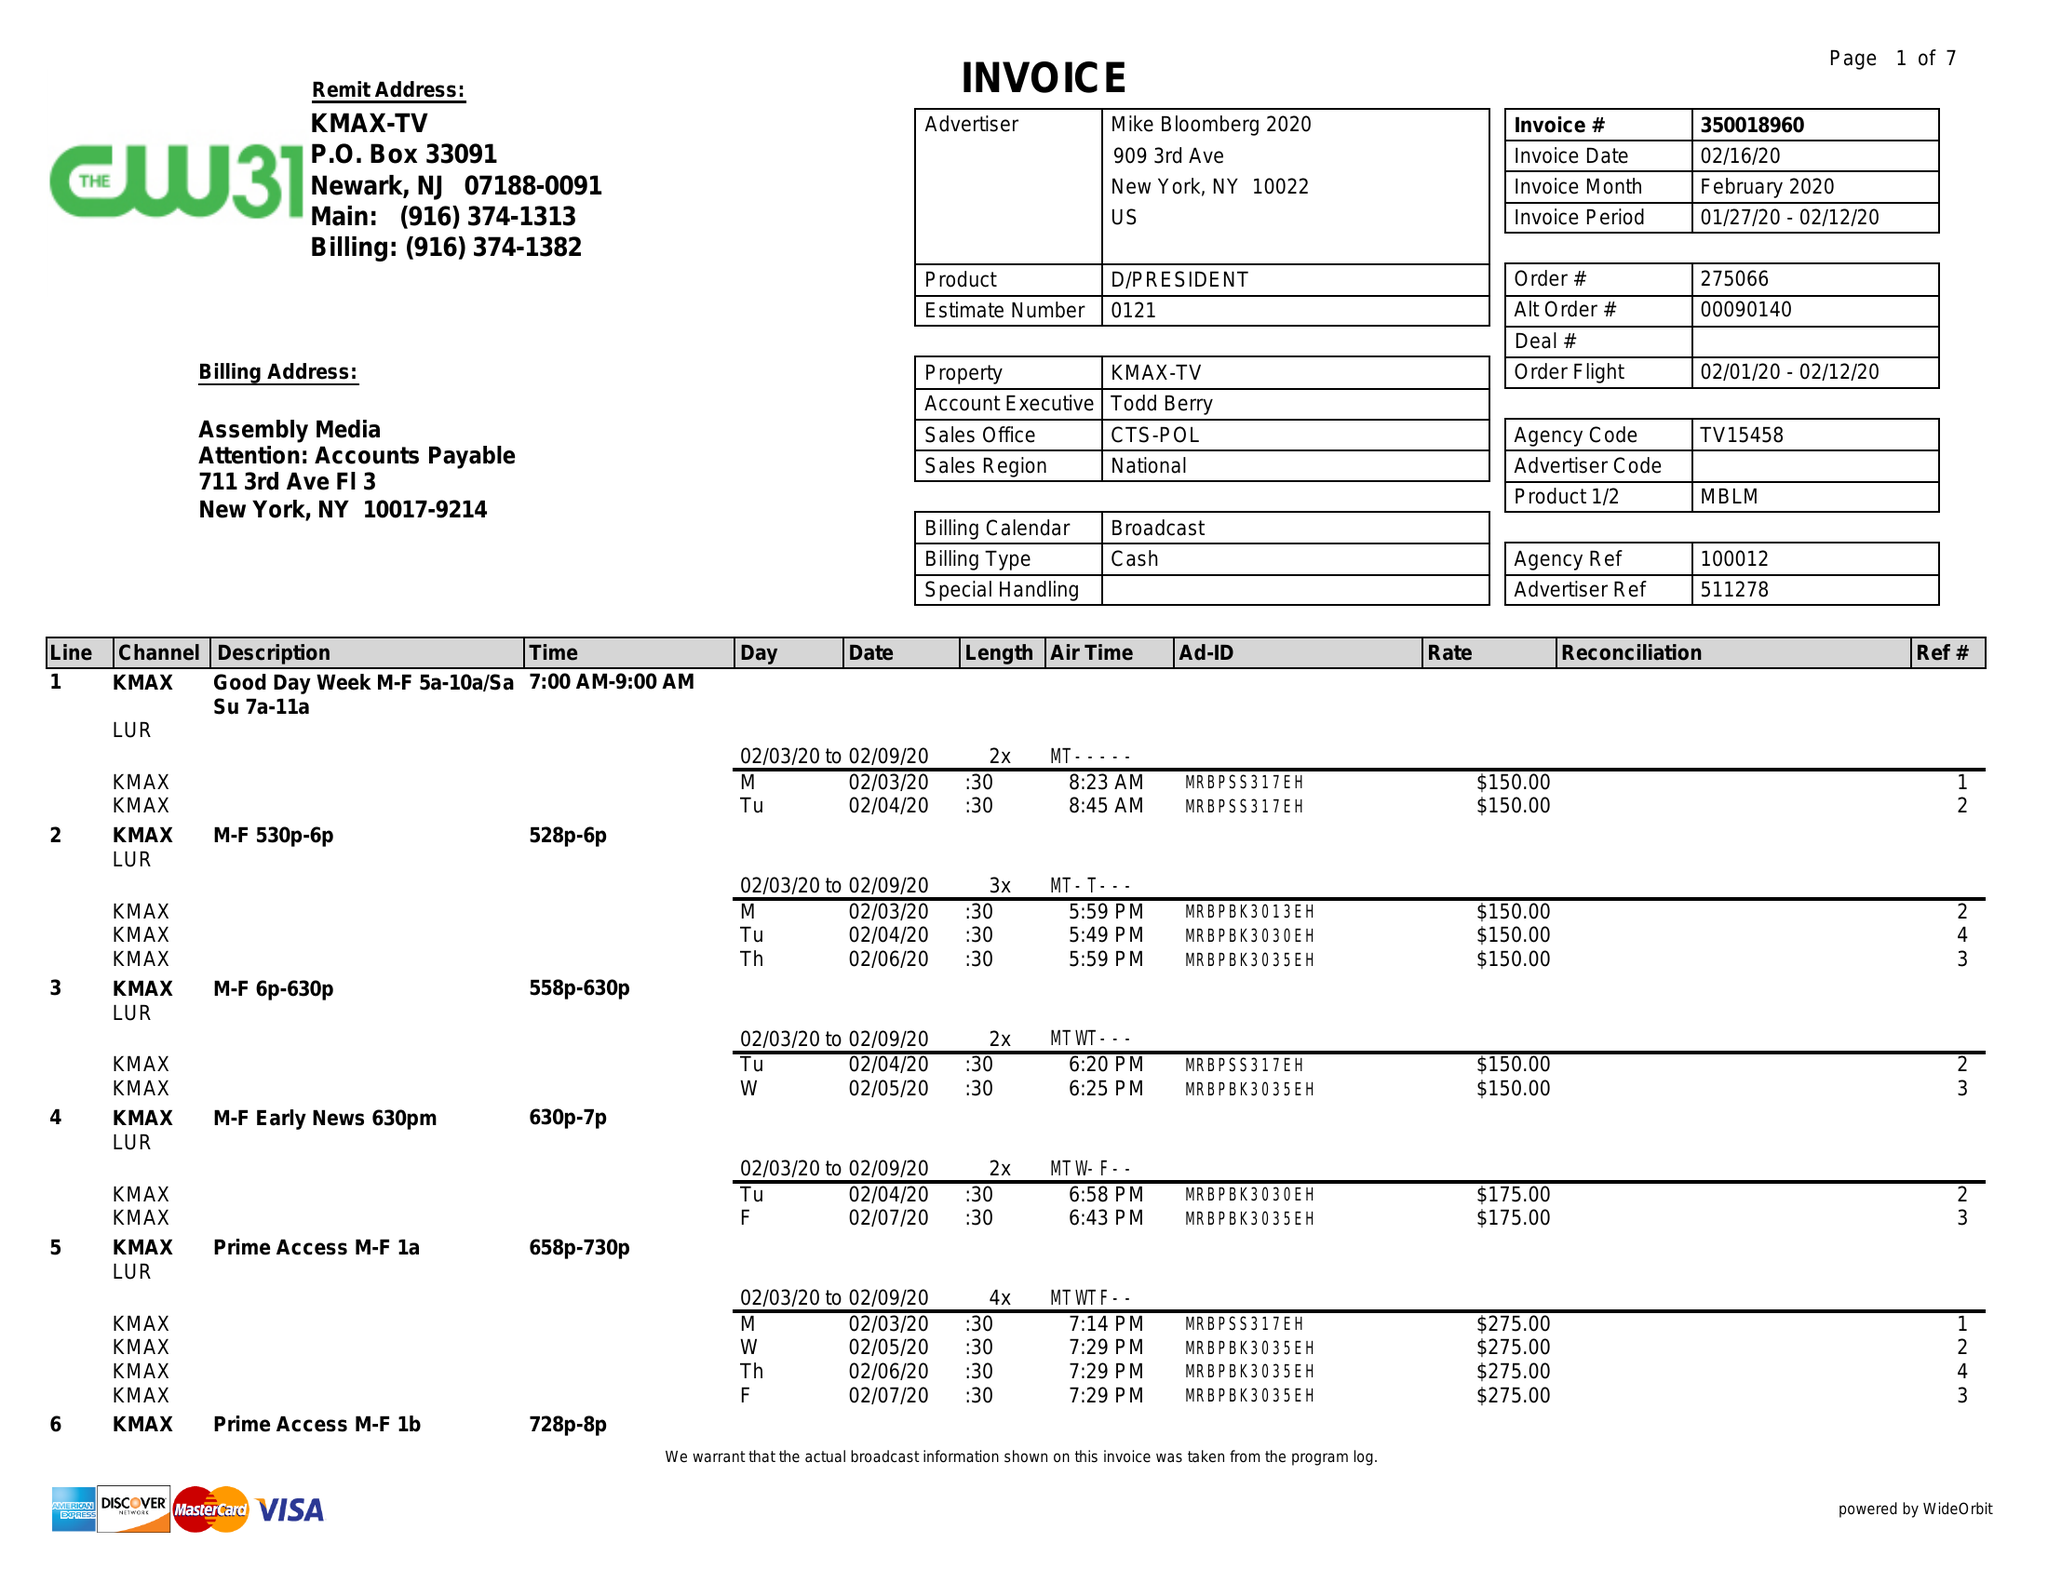What is the value for the flight_to?
Answer the question using a single word or phrase. 02/12/20 